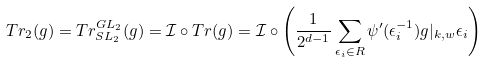Convert formula to latex. <formula><loc_0><loc_0><loc_500><loc_500>T r _ { 2 } ( g ) = T r ^ { G L _ { 2 } } _ { S L _ { 2 } } ( g ) = \mathcal { I } \circ T r ( g ) = \mathcal { I } \circ \left ( \frac { 1 } { 2 ^ { d - 1 } } \sum _ { \epsilon _ { i } \in R } \psi ^ { \prime } ( \epsilon _ { i } ^ { - 1 } ) g | _ { k , w } \epsilon _ { i } \right )</formula> 